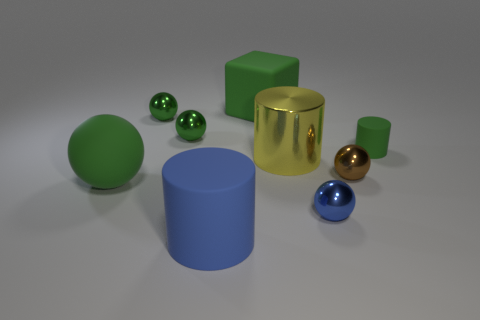What is the size of the rubber cylinder that is the same color as the rubber sphere?
Provide a succinct answer. Small. How many things are large green rubber objects in front of the yellow metal cylinder or green cylinders?
Provide a succinct answer. 2. There is a green rubber thing behind the green rubber thing to the right of the large rubber object that is behind the yellow shiny object; what is its size?
Your response must be concise. Large. What is the material of the large sphere that is the same color as the matte block?
Offer a very short reply. Rubber. Is there anything else that is the same shape as the tiny rubber object?
Offer a terse response. Yes. There is a blue thing to the right of the large cylinder that is in front of the big ball; how big is it?
Make the answer very short. Small. What number of big things are blue rubber blocks or green shiny balls?
Offer a terse response. 0. Are there fewer blue cylinders than tiny cyan matte objects?
Provide a succinct answer. No. Are there any other things that are the same size as the brown thing?
Your response must be concise. Yes. Is the color of the tiny cylinder the same as the metal cylinder?
Your response must be concise. No. 